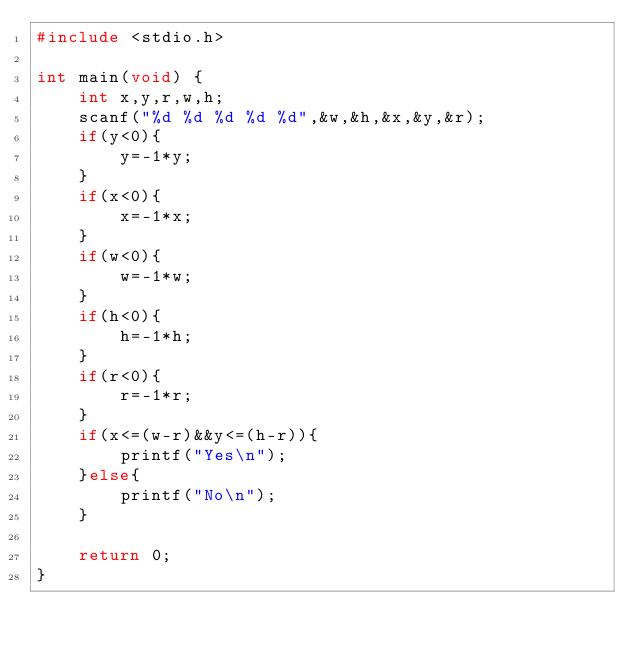<code> <loc_0><loc_0><loc_500><loc_500><_C_>#include <stdio.h>

int main(void) {
	int x,y,r,w,h;
	scanf("%d %d %d %d %d",&w,&h,&x,&y,&r);
	if(y<0){
		y=-1*y;
	}
	if(x<0){
		x=-1*x;
	}
	if(w<0){
		w=-1*w;
	}
	if(h<0){
		h=-1*h;
	}
	if(r<0){
		r=-1*r;
	}
	if(x<=(w-r)&&y<=(h-r)){
		printf("Yes\n");
	}else{
		printf("No\n");
	}
	
	return 0;
}</code> 